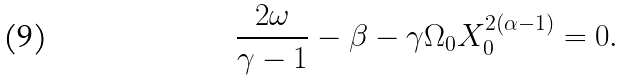Convert formula to latex. <formula><loc_0><loc_0><loc_500><loc_500>\frac { 2 \omega } { \gamma - 1 } - \beta - \gamma \Omega _ { 0 } X _ { 0 } ^ { 2 ( \alpha - 1 ) } = 0 .</formula> 